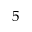Convert formula to latex. <formula><loc_0><loc_0><loc_500><loc_500>5</formula> 